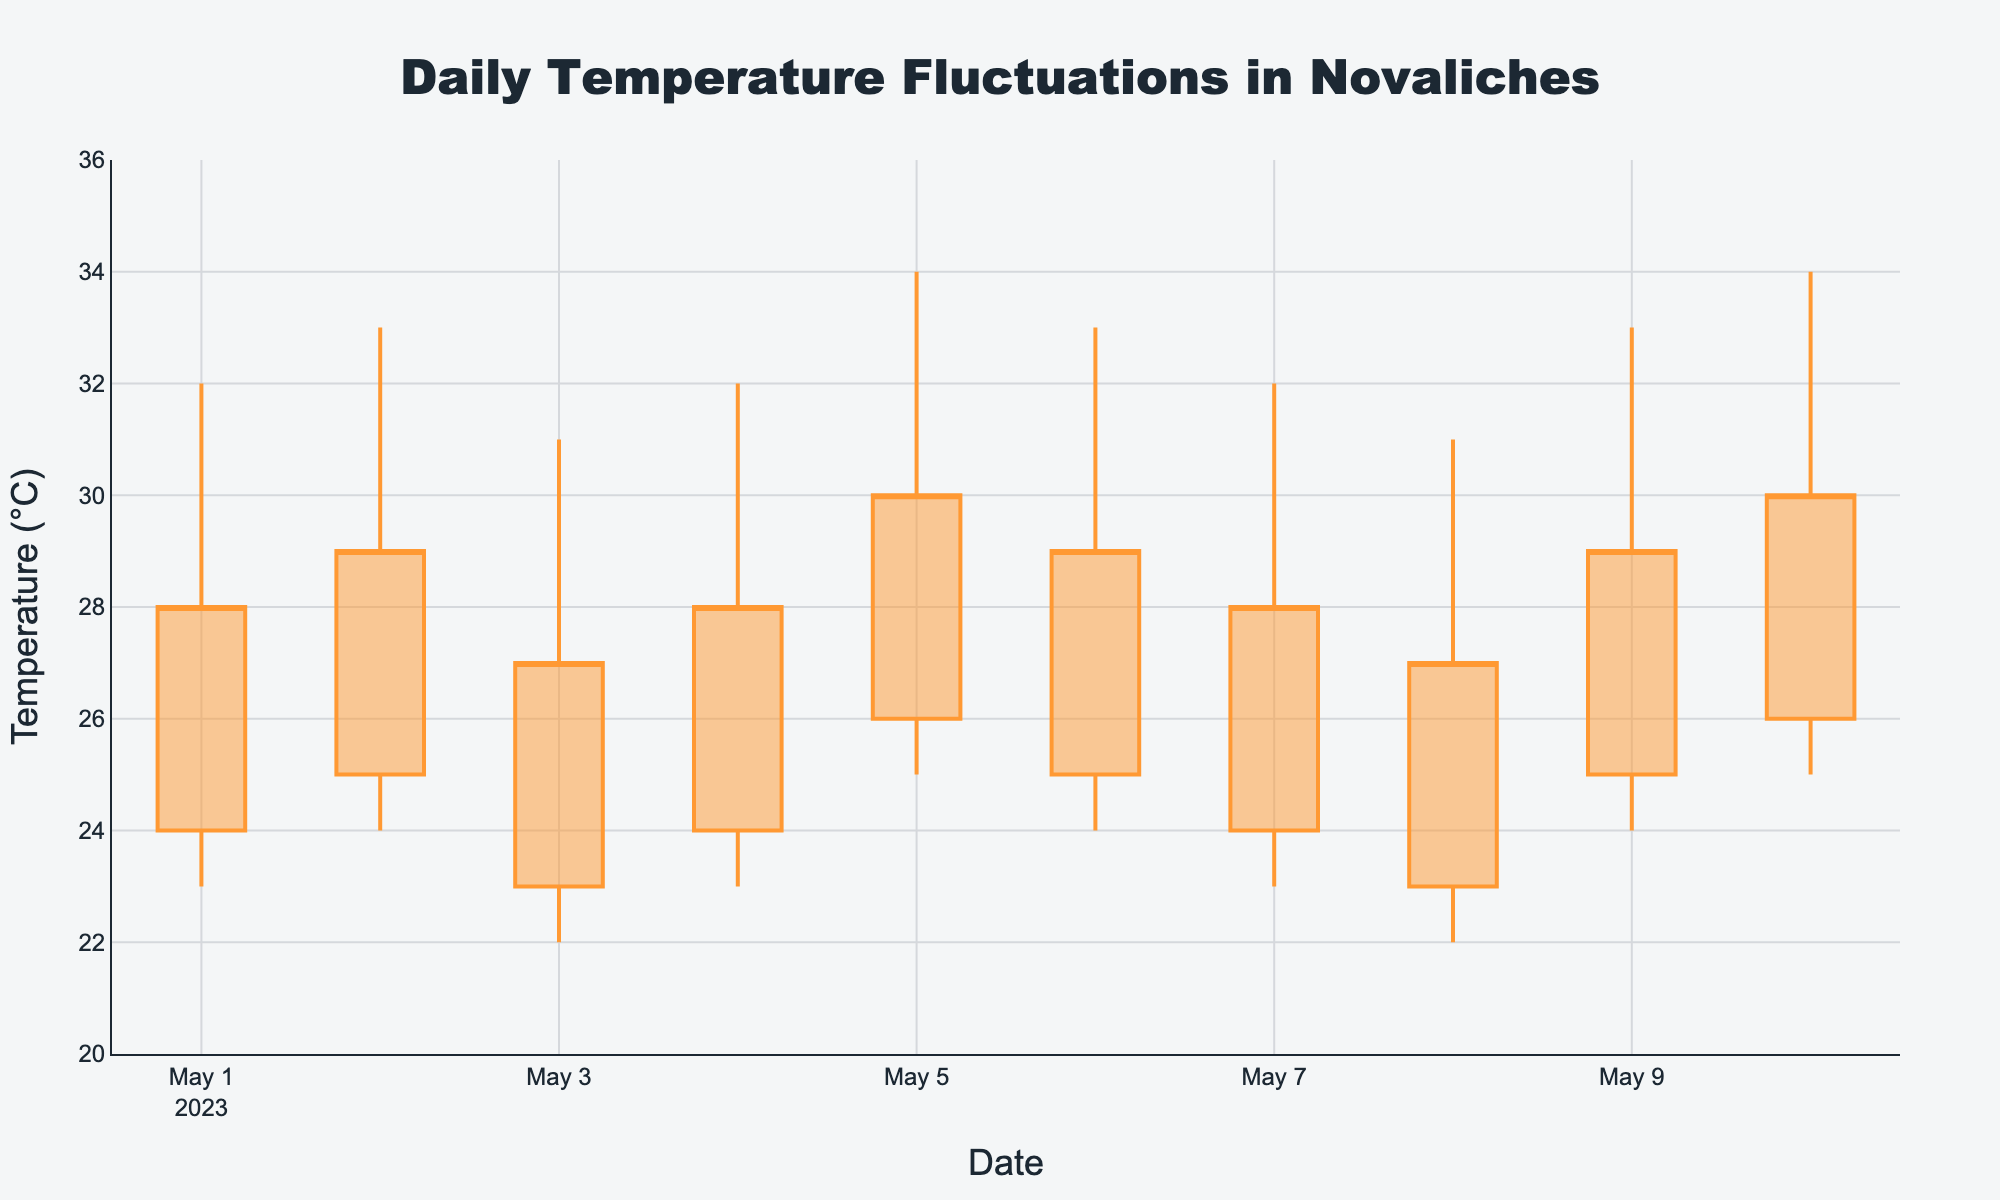What is the title of this figure? The title is located at the top center of the figure. It reads 'Daily Temperature Fluctuations in Novaliches'.
Answer: Daily Temperature Fluctuations in Novaliches How many days of data are represented in the figure? The x-axis represents the dates, and there are ten unique dates shown on the x-axis.
Answer: 10 What is the range of temperatures displayed on the y-axis? The y-axis range is indicated at the sides of the chart. It goes from 20°C to 36°C.
Answer: 20°C to 36°C Which day had the highest noon temperature? Look for the highest 'high' value among the candlesticks. The noon temperature is highest on 2023-05-05 and 2023-05-10, both reaching 34°C.
Answer: 2023-05-05 and 2023-05-10 On which date was the evening temperature equal to the morning temperature? Check the 'open' and 'close' values of each candlestick to see when they are the same. On 2023-05-01, the evening temperature was equal to the morning temperature, both at 24°C.
Answer: 2023-05-01 What is the average morning temperature over the given dates? Sum the morning temperatures and divide by the number of days: (24 + 25 + 23 + 24 + 26 + 25 + 24 + 23 + 25 + 26)/10 = 24.5°C.
Answer: 24.5°C Which day had the smallest temperature range? Calculate the range for each day (noon – night) and find the smallest. For example, on 2023-05-03, the range is (31-22) = 9°C which is the smallest.
Answer: 2023-05-03 How do the morning temperatures generally compare to the night temperatures? Analyze the 'open' and 'low' values and observe the general trend. Morning temperatures are generally higher than night temperatures across all days.
Answer: Morning temperatures are higher Which days had decreasing evening temperatures from the previous night? Compare the 'close' value of each day with the 'close' value of the previous day. 2023-05-01, 2023-05-03, and 2023-05-08 had decreasing evening temperatures from the previous night.
Answer: 2023-05-01, 2023-05-03, and 2023-05-08 Did the temperature ever fall to 22°C at night? Look at the 'low' values which represent night temperatures. On 2023-05-03 and 2023-05-08, the night temperature fell to 22°C.
Answer: Yes, on 2023-05-03 and 2023-05-08 